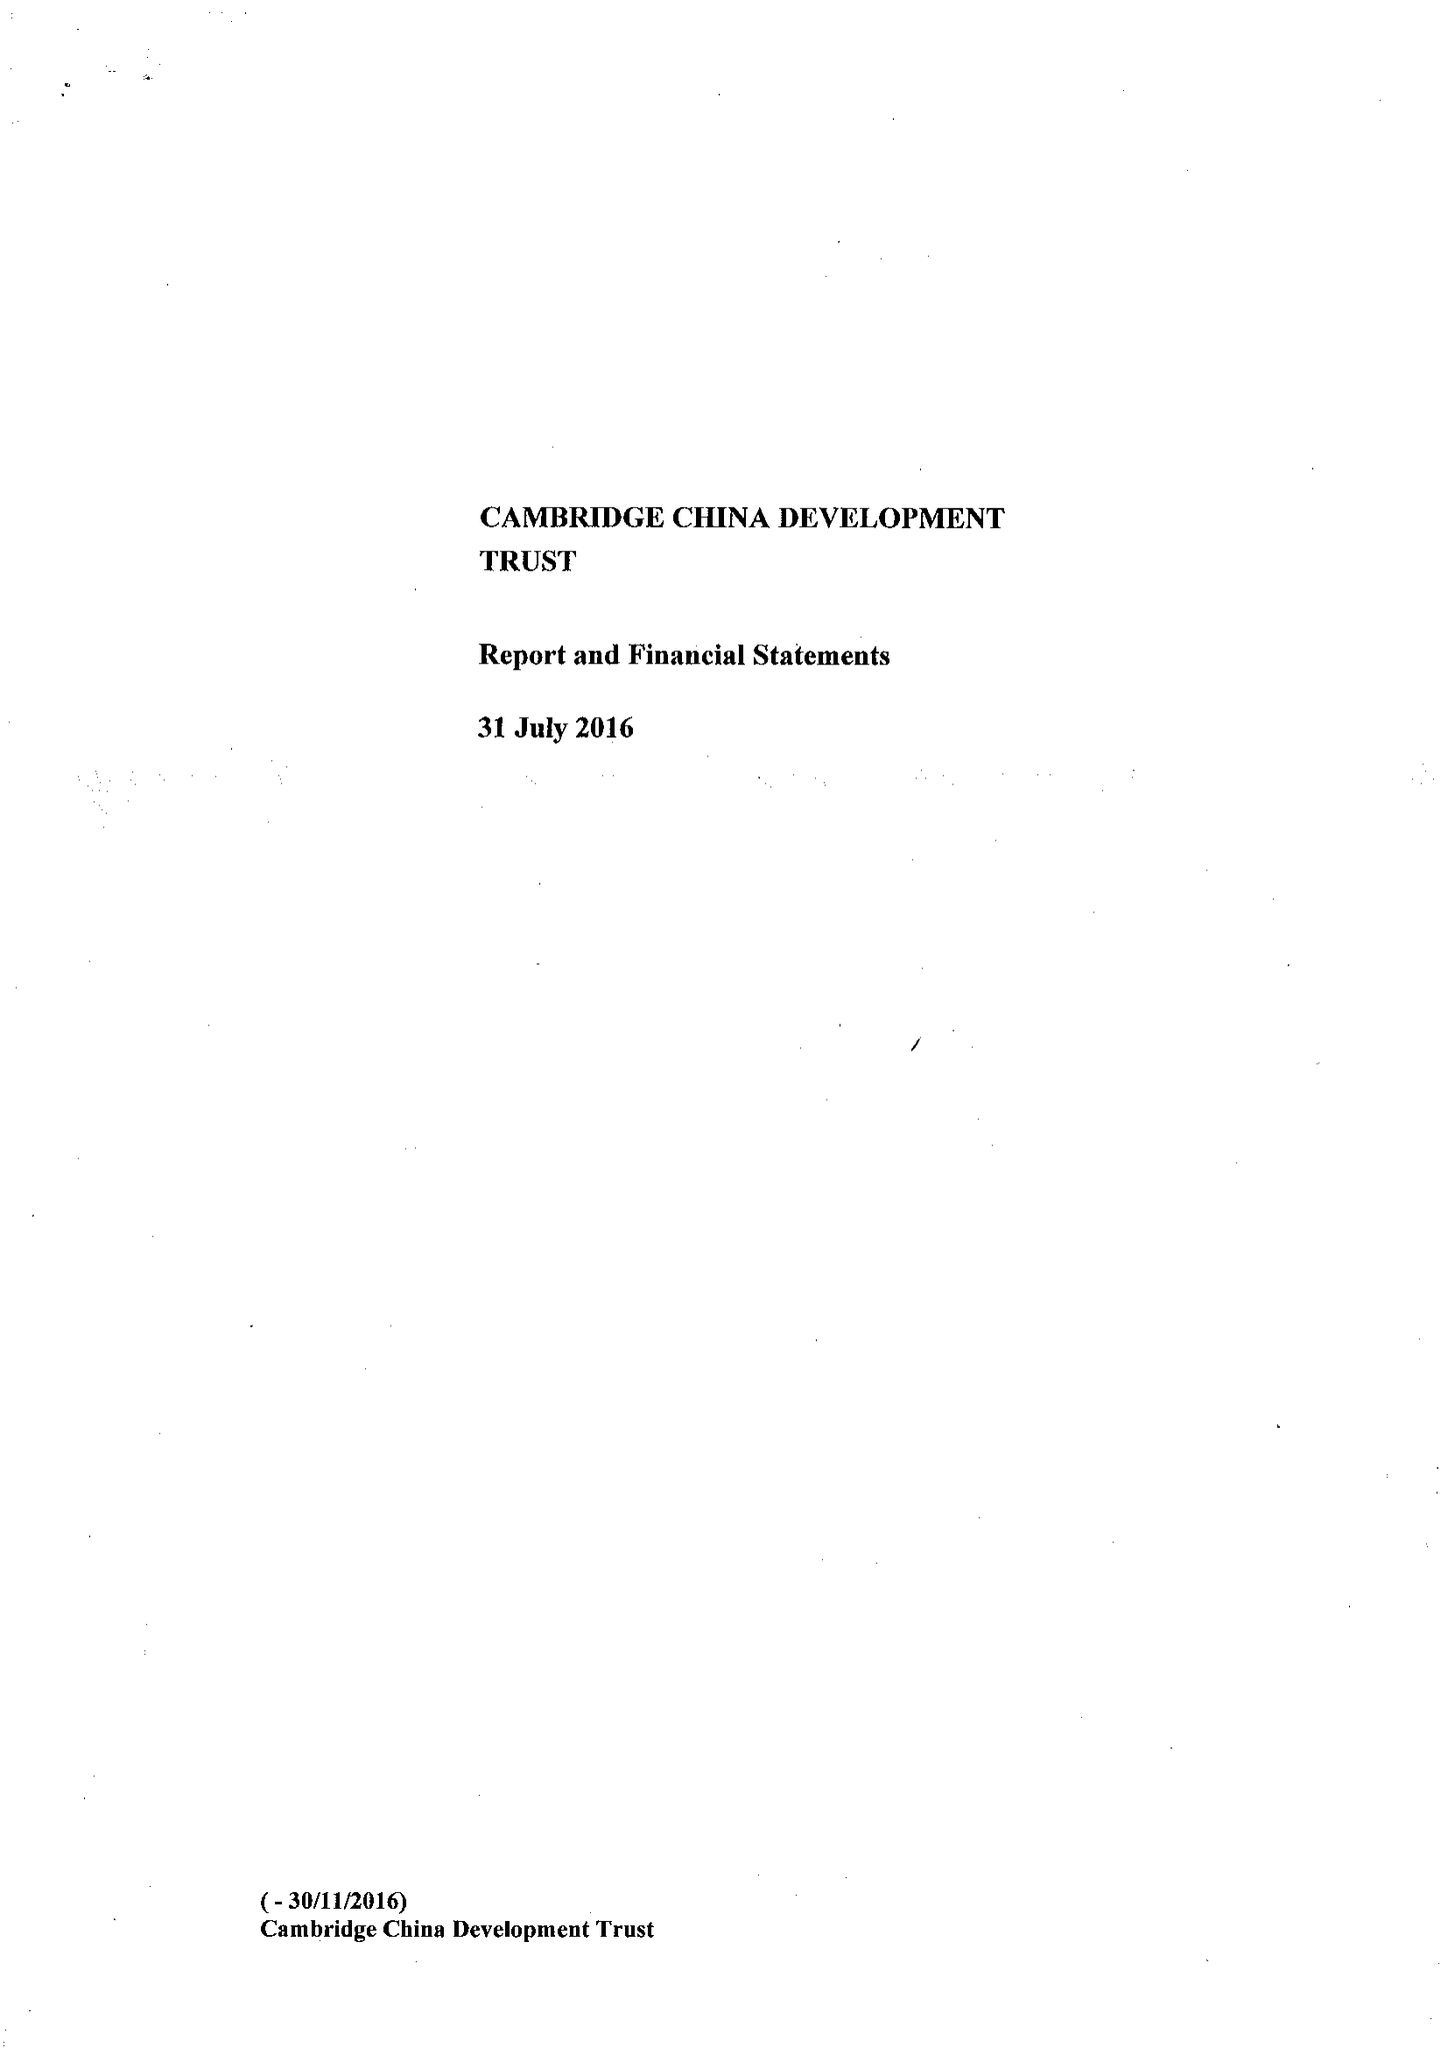What is the value for the address__postcode?
Answer the question using a single word or phrase. CB2 1TQ 